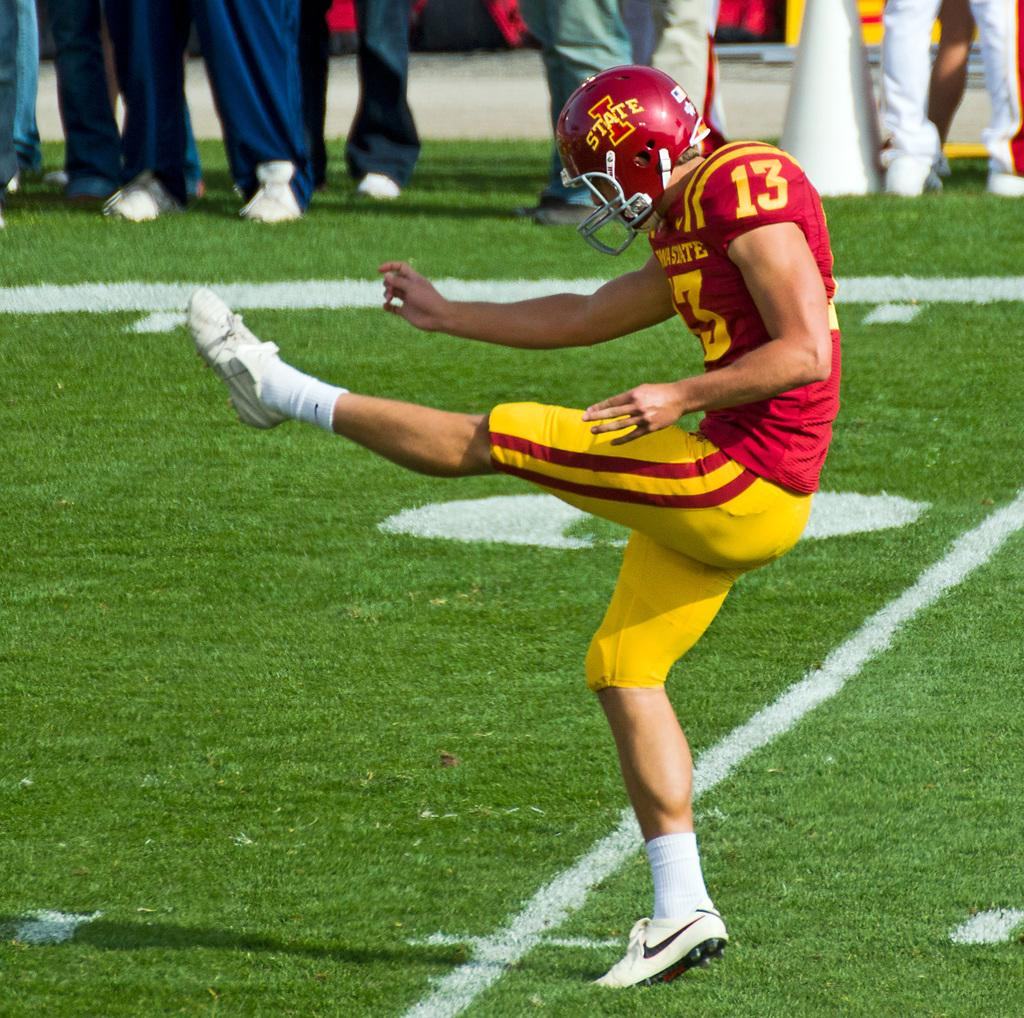What is the person in the image wearing? The person is wearing a yellow and red color dress. What type of protective gear is the person wearing? The person is wearing a helmet. Can you describe the people in the background of the image? There are people standing in the background of the image. What type of circle is being drawn by the person in the image? There is no circle being drawn in the image; the person is wearing a helmet and standing in a dress. 